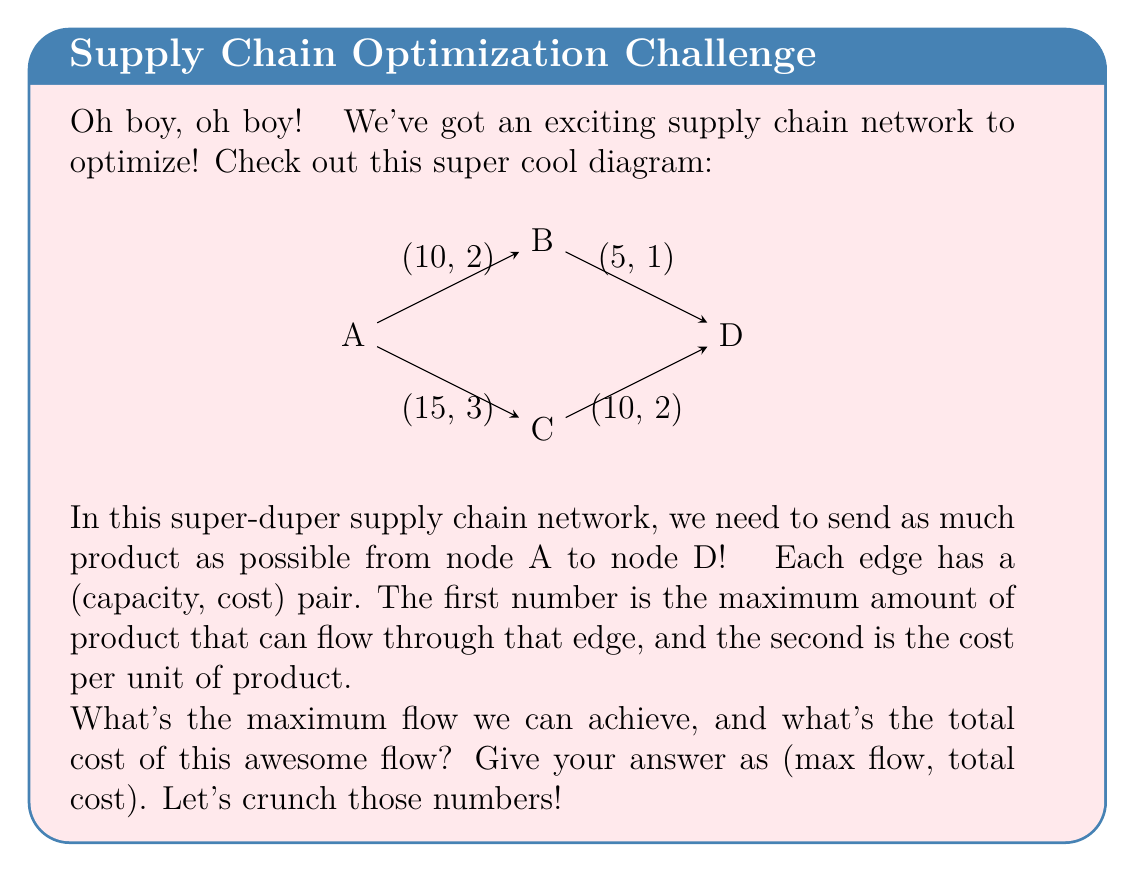Provide a solution to this math problem. Alrighty, let's break this down step by step! 🎈

1) First, we need to find the maximum flow. We can use the Ford-Fulkerson algorithm for this:

   a) Path A -> B -> D: min(10, 5) = 5
   b) Path A -> C -> D: min(15, 10) = 10
   
   Total max flow = 5 + 10 = 15

2) Now that we know the max flow, let's calculate the cost:

   a) Path A -> B -> D: 
      Flow: 5
      Cost: 5 * (2 + 1) = 15

   b) Path A -> C -> D:
      Flow: 10
      Cost: 10 * (3 + 2) = 50

3) Total cost:
   15 + 50 = 65

Wowza! 🎊 We've found our solution! The maximum flow is 15 units, and the total cost for this flow is 65.

Let's double-check:
- All capacity constraints are satisfied
- Flow is conserved at each node
- We can't push any more flow through the network

It's perfect! 🌟
Answer: (15, 65) 